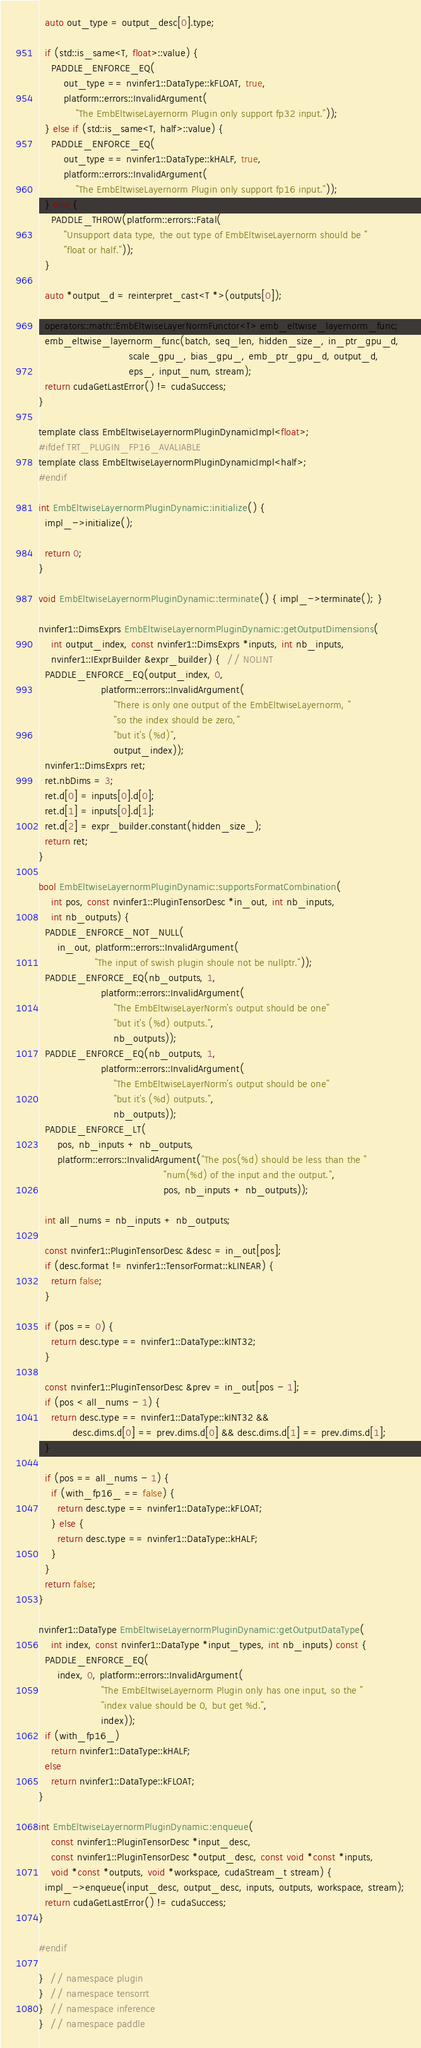Convert code to text. <code><loc_0><loc_0><loc_500><loc_500><_Cuda_>
  auto out_type = output_desc[0].type;

  if (std::is_same<T, float>::value) {
    PADDLE_ENFORCE_EQ(
        out_type == nvinfer1::DataType::kFLOAT, true,
        platform::errors::InvalidArgument(
            "The EmbEltwiseLayernorm Plugin only support fp32 input."));
  } else if (std::is_same<T, half>::value) {
    PADDLE_ENFORCE_EQ(
        out_type == nvinfer1::DataType::kHALF, true,
        platform::errors::InvalidArgument(
            "The EmbEltwiseLayernorm Plugin only support fp16 input."));
  } else {
    PADDLE_THROW(platform::errors::Fatal(
        "Unsupport data type, the out type of EmbEltwiseLayernorm should be "
        "float or half."));
  }

  auto *output_d = reinterpret_cast<T *>(outputs[0]);

  operators::math::EmbEltwiseLayerNormFunctor<T> emb_eltwise_layernorm_func;
  emb_eltwise_layernorm_func(batch, seq_len, hidden_size_, in_ptr_gpu_d,
                             scale_gpu_, bias_gpu_, emb_ptr_gpu_d, output_d,
                             eps_, input_num, stream);
  return cudaGetLastError() != cudaSuccess;
}

template class EmbEltwiseLayernormPluginDynamicImpl<float>;
#ifdef TRT_PLUGIN_FP16_AVALIABLE
template class EmbEltwiseLayernormPluginDynamicImpl<half>;
#endif

int EmbEltwiseLayernormPluginDynamic::initialize() {
  impl_->initialize();

  return 0;
}

void EmbEltwiseLayernormPluginDynamic::terminate() { impl_->terminate(); }

nvinfer1::DimsExprs EmbEltwiseLayernormPluginDynamic::getOutputDimensions(
    int output_index, const nvinfer1::DimsExprs *inputs, int nb_inputs,
    nvinfer1::IExprBuilder &expr_builder) {  // NOLINT
  PADDLE_ENFORCE_EQ(output_index, 0,
                    platform::errors::InvalidArgument(
                        "There is only one output of the EmbEltwiseLayernorm, "
                        "so the index should be zero,"
                        "but it's (%d)",
                        output_index));
  nvinfer1::DimsExprs ret;
  ret.nbDims = 3;
  ret.d[0] = inputs[0].d[0];
  ret.d[1] = inputs[0].d[1];
  ret.d[2] = expr_builder.constant(hidden_size_);
  return ret;
}

bool EmbEltwiseLayernormPluginDynamic::supportsFormatCombination(
    int pos, const nvinfer1::PluginTensorDesc *in_out, int nb_inputs,
    int nb_outputs) {
  PADDLE_ENFORCE_NOT_NULL(
      in_out, platform::errors::InvalidArgument(
                  "The input of swish plugin shoule not be nullptr."));
  PADDLE_ENFORCE_EQ(nb_outputs, 1,
                    platform::errors::InvalidArgument(
                        "The EmbEltwiseLayerNorm's output should be one"
                        "but it's (%d) outputs.",
                        nb_outputs));
  PADDLE_ENFORCE_EQ(nb_outputs, 1,
                    platform::errors::InvalidArgument(
                        "The EmbEltwiseLayerNorm's output should be one"
                        "but it's (%d) outputs.",
                        nb_outputs));
  PADDLE_ENFORCE_LT(
      pos, nb_inputs + nb_outputs,
      platform::errors::InvalidArgument("The pos(%d) should be less than the "
                                        "num(%d) of the input and the output.",
                                        pos, nb_inputs + nb_outputs));

  int all_nums = nb_inputs + nb_outputs;

  const nvinfer1::PluginTensorDesc &desc = in_out[pos];
  if (desc.format != nvinfer1::TensorFormat::kLINEAR) {
    return false;
  }

  if (pos == 0) {
    return desc.type == nvinfer1::DataType::kINT32;
  }

  const nvinfer1::PluginTensorDesc &prev = in_out[pos - 1];
  if (pos < all_nums - 1) {
    return desc.type == nvinfer1::DataType::kINT32 &&
           desc.dims.d[0] == prev.dims.d[0] && desc.dims.d[1] == prev.dims.d[1];
  }

  if (pos == all_nums - 1) {
    if (with_fp16_ == false) {
      return desc.type == nvinfer1::DataType::kFLOAT;
    } else {
      return desc.type == nvinfer1::DataType::kHALF;
    }
  }
  return false;
}

nvinfer1::DataType EmbEltwiseLayernormPluginDynamic::getOutputDataType(
    int index, const nvinfer1::DataType *input_types, int nb_inputs) const {
  PADDLE_ENFORCE_EQ(
      index, 0, platform::errors::InvalidArgument(
                    "The EmbEltwiseLayernorm Plugin only has one input, so the "
                    "index value should be 0, but get %d.",
                    index));
  if (with_fp16_)
    return nvinfer1::DataType::kHALF;
  else
    return nvinfer1::DataType::kFLOAT;
}

int EmbEltwiseLayernormPluginDynamic::enqueue(
    const nvinfer1::PluginTensorDesc *input_desc,
    const nvinfer1::PluginTensorDesc *output_desc, const void *const *inputs,
    void *const *outputs, void *workspace, cudaStream_t stream) {
  impl_->enqueue(input_desc, output_desc, inputs, outputs, workspace, stream);
  return cudaGetLastError() != cudaSuccess;
}

#endif

}  // namespace plugin
}  // namespace tensorrt
}  // namespace inference
}  // namespace paddle
</code> 